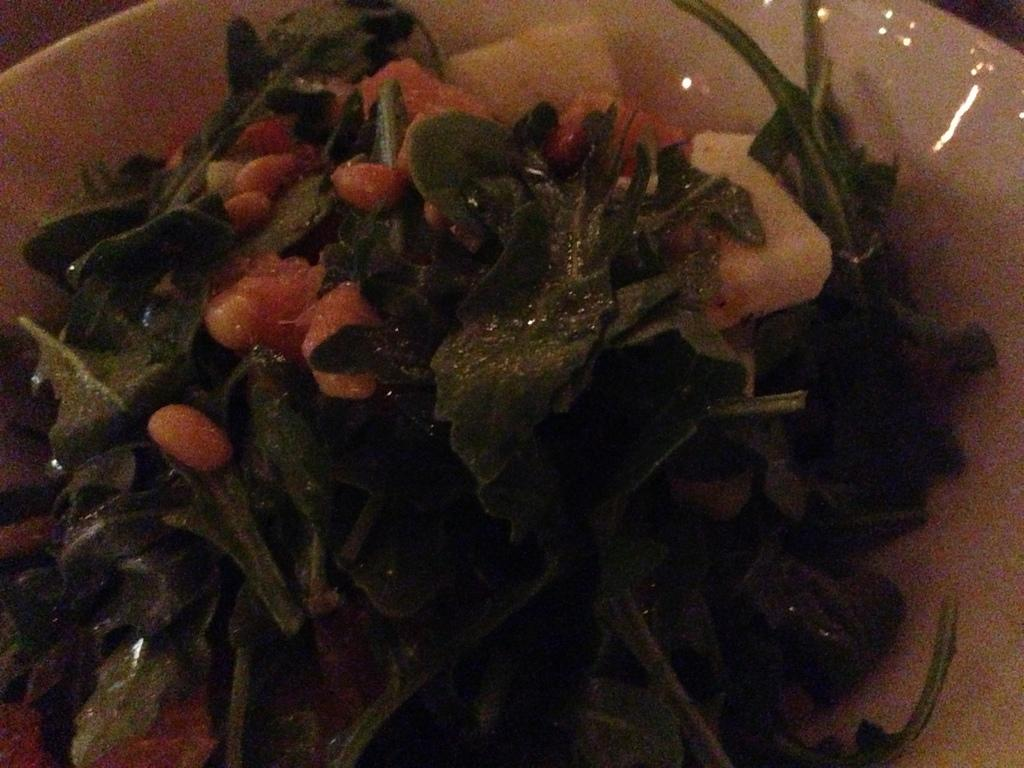What is on the plate in the image? There is a plate containing food in the image. Can you see a bat flying around the food on the plate in the image? No, there is no bat present in the image. 